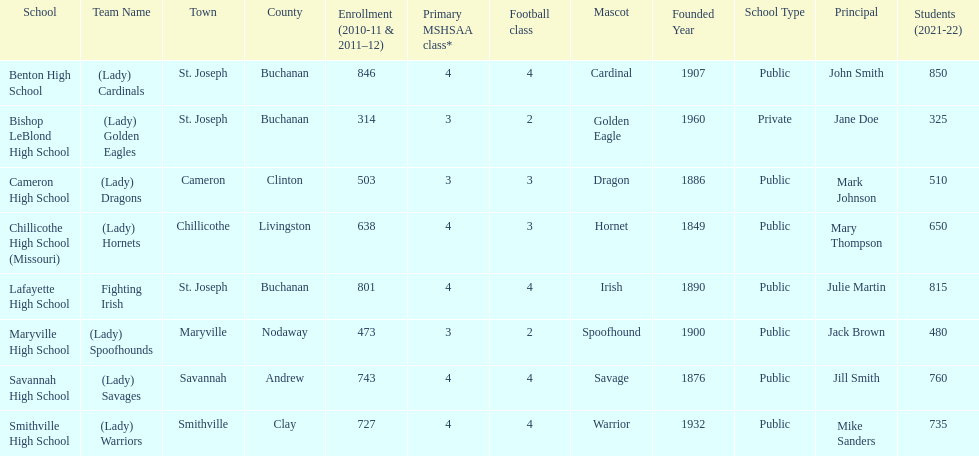How many schools are there in this conference? 8. 